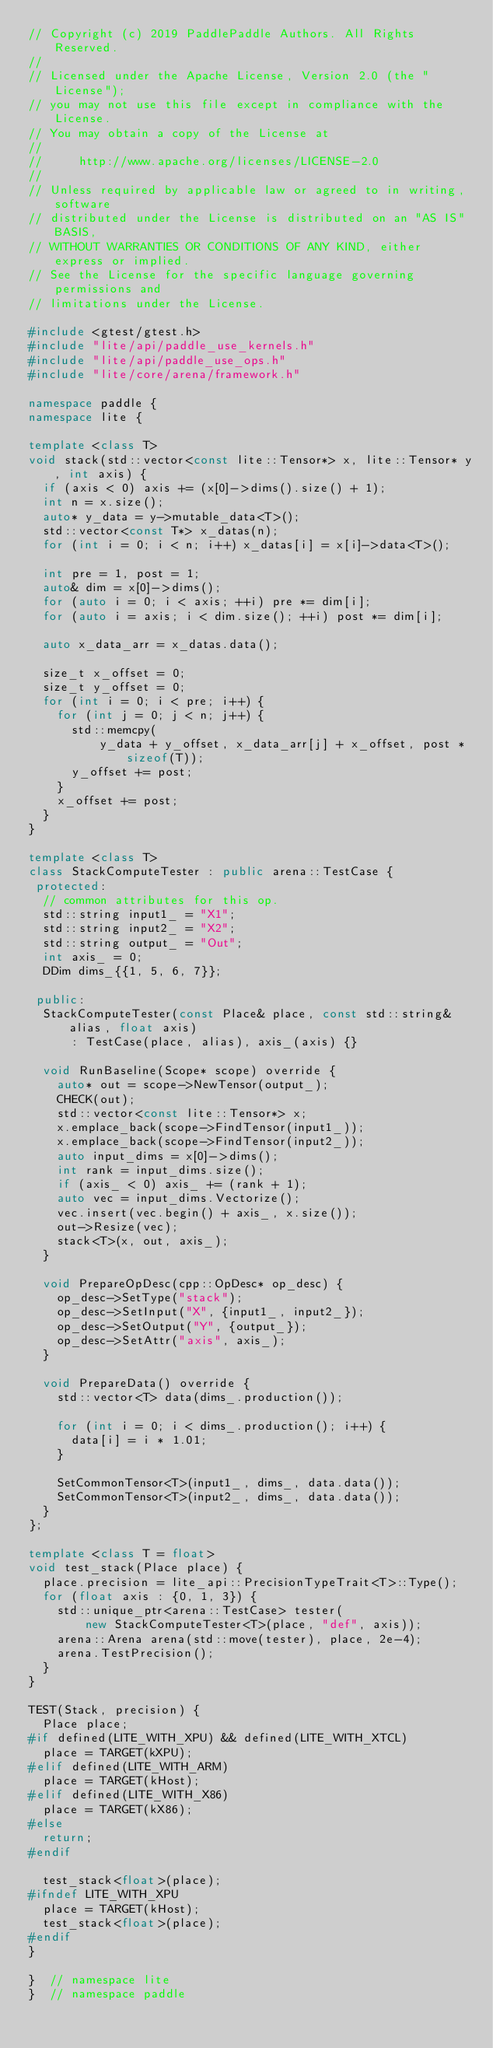Convert code to text. <code><loc_0><loc_0><loc_500><loc_500><_C++_>// Copyright (c) 2019 PaddlePaddle Authors. All Rights Reserved.
//
// Licensed under the Apache License, Version 2.0 (the "License");
// you may not use this file except in compliance with the License.
// You may obtain a copy of the License at
//
//     http://www.apache.org/licenses/LICENSE-2.0
//
// Unless required by applicable law or agreed to in writing, software
// distributed under the License is distributed on an "AS IS" BASIS,
// WITHOUT WARRANTIES OR CONDITIONS OF ANY KIND, either express or implied.
// See the License for the specific language governing permissions and
// limitations under the License.

#include <gtest/gtest.h>
#include "lite/api/paddle_use_kernels.h"
#include "lite/api/paddle_use_ops.h"
#include "lite/core/arena/framework.h"

namespace paddle {
namespace lite {

template <class T>
void stack(std::vector<const lite::Tensor*> x, lite::Tensor* y, int axis) {
  if (axis < 0) axis += (x[0]->dims().size() + 1);
  int n = x.size();
  auto* y_data = y->mutable_data<T>();
  std::vector<const T*> x_datas(n);
  for (int i = 0; i < n; i++) x_datas[i] = x[i]->data<T>();

  int pre = 1, post = 1;
  auto& dim = x[0]->dims();
  for (auto i = 0; i < axis; ++i) pre *= dim[i];
  for (auto i = axis; i < dim.size(); ++i) post *= dim[i];

  auto x_data_arr = x_datas.data();

  size_t x_offset = 0;
  size_t y_offset = 0;
  for (int i = 0; i < pre; i++) {
    for (int j = 0; j < n; j++) {
      std::memcpy(
          y_data + y_offset, x_data_arr[j] + x_offset, post * sizeof(T));
      y_offset += post;
    }
    x_offset += post;
  }
}

template <class T>
class StackComputeTester : public arena::TestCase {
 protected:
  // common attributes for this op.
  std::string input1_ = "X1";
  std::string input2_ = "X2";
  std::string output_ = "Out";
  int axis_ = 0;
  DDim dims_{{1, 5, 6, 7}};

 public:
  StackComputeTester(const Place& place, const std::string& alias, float axis)
      : TestCase(place, alias), axis_(axis) {}

  void RunBaseline(Scope* scope) override {
    auto* out = scope->NewTensor(output_);
    CHECK(out);
    std::vector<const lite::Tensor*> x;
    x.emplace_back(scope->FindTensor(input1_));
    x.emplace_back(scope->FindTensor(input2_));
    auto input_dims = x[0]->dims();
    int rank = input_dims.size();
    if (axis_ < 0) axis_ += (rank + 1);
    auto vec = input_dims.Vectorize();
    vec.insert(vec.begin() + axis_, x.size());
    out->Resize(vec);
    stack<T>(x, out, axis_);
  }

  void PrepareOpDesc(cpp::OpDesc* op_desc) {
    op_desc->SetType("stack");
    op_desc->SetInput("X", {input1_, input2_});
    op_desc->SetOutput("Y", {output_});
    op_desc->SetAttr("axis", axis_);
  }

  void PrepareData() override {
    std::vector<T> data(dims_.production());

    for (int i = 0; i < dims_.production(); i++) {
      data[i] = i * 1.01;
    }

    SetCommonTensor<T>(input1_, dims_, data.data());
    SetCommonTensor<T>(input2_, dims_, data.data());
  }
};

template <class T = float>
void test_stack(Place place) {
  place.precision = lite_api::PrecisionTypeTrait<T>::Type();
  for (float axis : {0, 1, 3}) {
    std::unique_ptr<arena::TestCase> tester(
        new StackComputeTester<T>(place, "def", axis));
    arena::Arena arena(std::move(tester), place, 2e-4);
    arena.TestPrecision();
  }
}

TEST(Stack, precision) {
  Place place;
#if defined(LITE_WITH_XPU) && defined(LITE_WITH_XTCL)
  place = TARGET(kXPU);
#elif defined(LITE_WITH_ARM)
  place = TARGET(kHost);
#elif defined(LITE_WITH_X86)
  place = TARGET(kX86);
#else
  return;
#endif

  test_stack<float>(place);
#ifndef LITE_WITH_XPU
  place = TARGET(kHost);
  test_stack<float>(place);
#endif
}

}  // namespace lite
}  // namespace paddle
</code> 